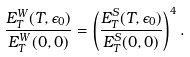Convert formula to latex. <formula><loc_0><loc_0><loc_500><loc_500>\frac { E _ { T } ^ { W } ( T , \epsilon _ { 0 } ) } { E _ { T } ^ { W } ( 0 , 0 ) } = \left ( \frac { E _ { T } ^ { S } ( T , \epsilon _ { 0 } ) } { E _ { T } ^ { S } ( 0 , 0 ) } \right ) ^ { 4 } .</formula> 